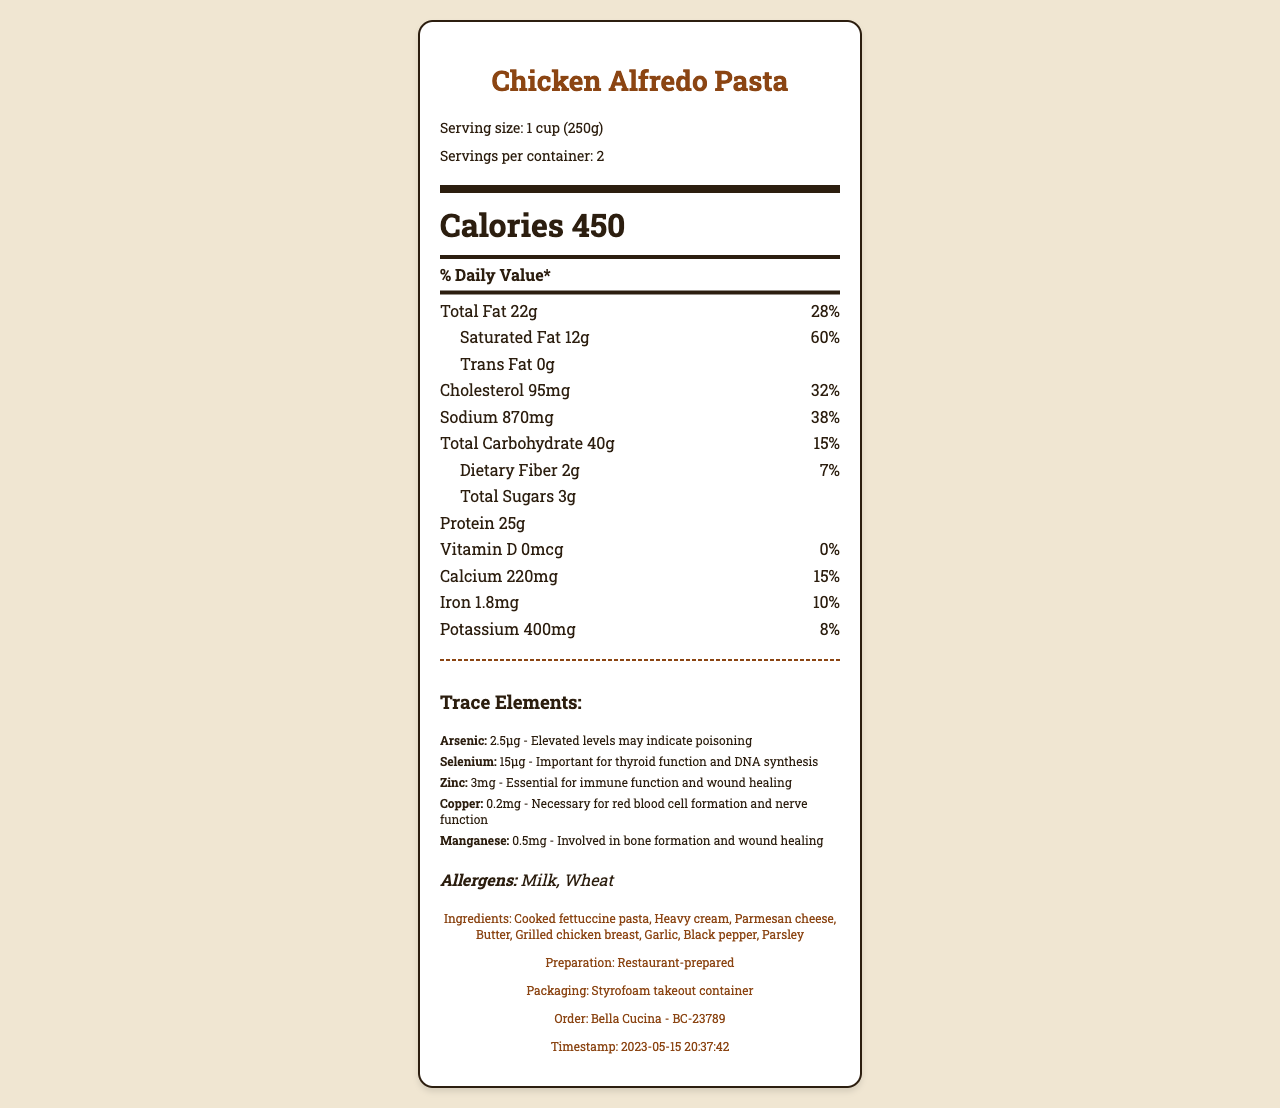who prepared the Chicken Alfredo Pasta? The footer of the document states that the preparation was done by "Bella Cucina."
Answer: Bella Cucina how many servings are in the container? The header of the document mentions "Servings per container: 2."
Answer: 2 what is the amount of saturated fat in one serving? The document specifies "Saturated Fat 12g" in the nutrient section.
Answer: 12g what timing information is available about the meal? The footer of the document mentions the timestamp "2023-05-15 20:37:42."
Answer: 2023-05-15 20:37:42 what allergens are present in this meal? The allergens section of the document lists "Milk" and "Wheat."
Answer: Milk, Wheat what is the significance of arsenic in the trace elements? A. Important for bone formation B. Involved in DNA synthesis C. Elevated levels may indicate poisoning D. Essential for wound healing In the trace elements section, it states that elevated levels of arsenic "may indicate poisoning."
Answer: C which nutrient has the highest daily value percentage? A. Vitamin D B. Saturated Fat C. Dietary Fiber D. Potassium The document states "Saturated Fat 60%" which is the highest daily value percentage compared to Vitamin D (0%), Dietary Fiber (7%), and Potassium (8%).
Answer: B is there any sugar in the Chicken Alfredo Pasta? The nutrient section mentions "Total Sugars 3g."
Answer: Yes does the Chicken Alfredo Pasta contain any vitamin D? The document specifies "Vitamin D 0mcg" and "0%" daily value.
Answer: No how would you summarize the document? The document provides a comprehensive overview of the nutritional content, stating the macronutrients, micronutrients, and trace elements. It also includes allergen information and preparation details from the restaurant "Bella Cucina" with a timestamp, emphasizing that it was served in a Styrofoam takeout container.
Answer: The document is a Nutrition Facts Label for Chicken Alfredo Pasta, detailing its nutritional content, trace elements, allergens, ingredients, preparation method, packaging, and purchase details. does the document mention if the meal contained pesticides? The document doesn't provide any information regarding the presence or absence of pesticides.
Answer: Cannot be determined 